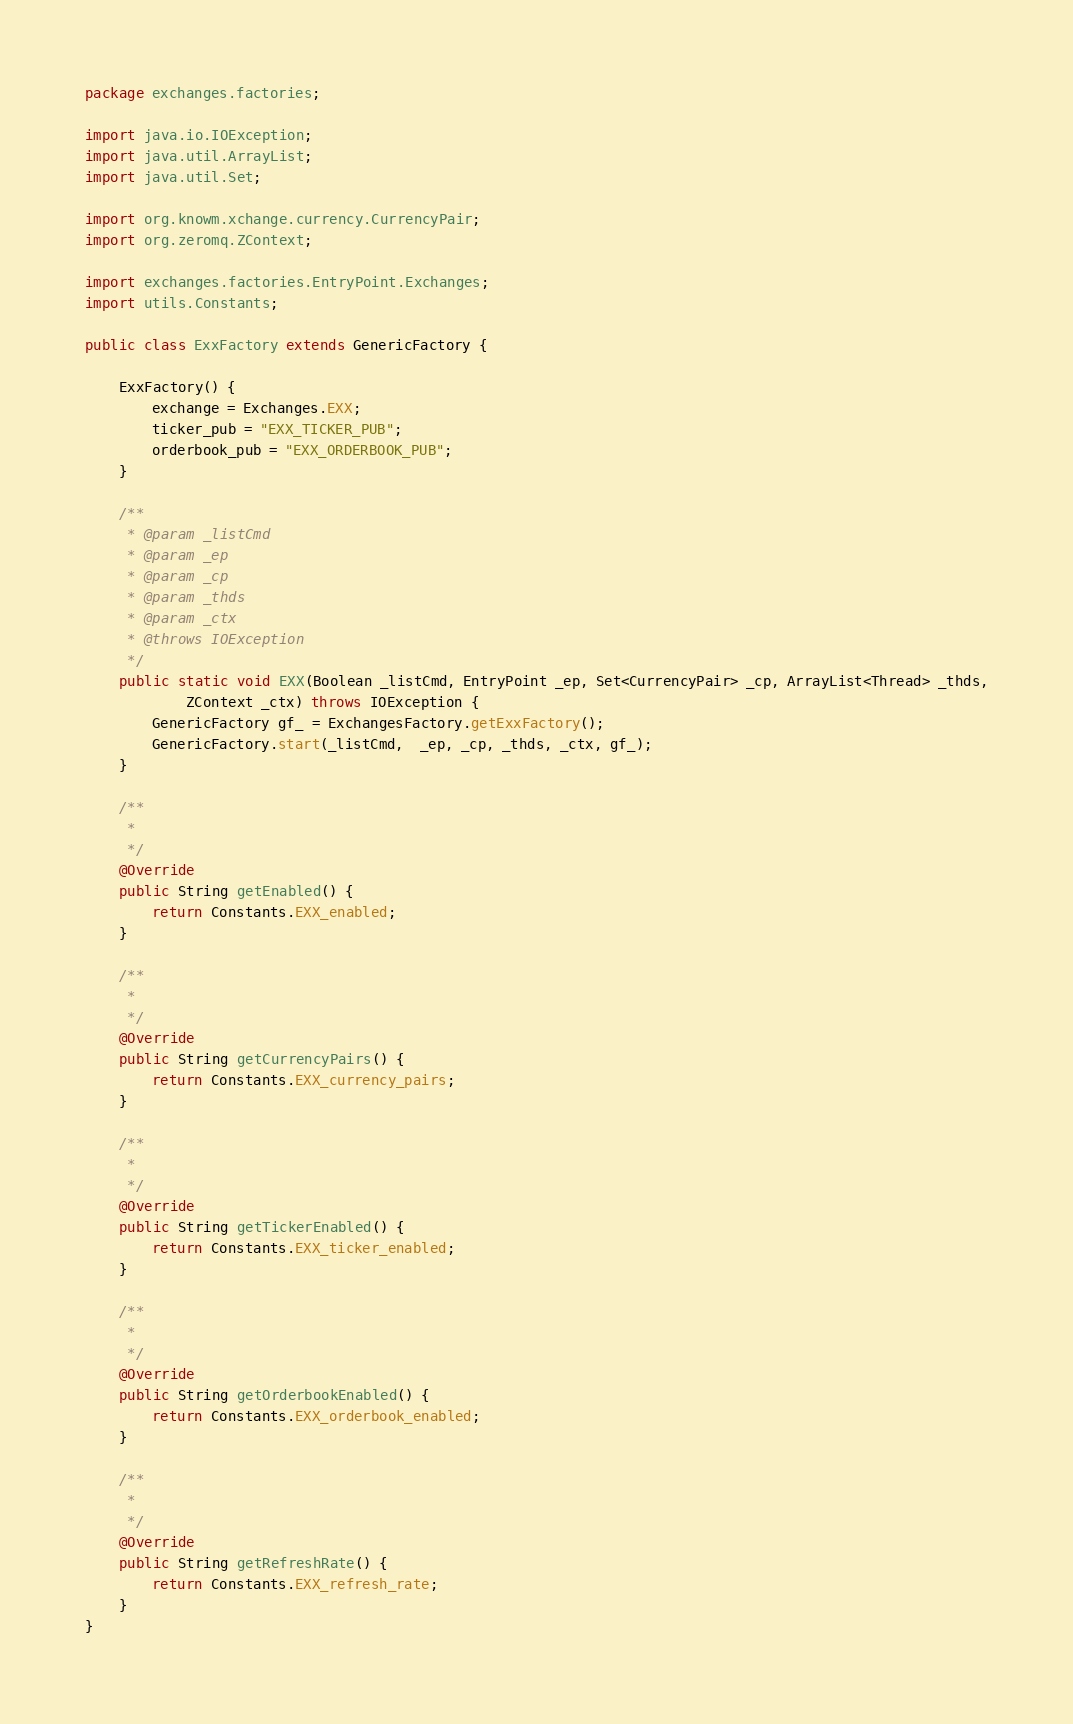Convert code to text. <code><loc_0><loc_0><loc_500><loc_500><_Java_>package exchanges.factories;

import java.io.IOException;
import java.util.ArrayList;
import java.util.Set;

import org.knowm.xchange.currency.CurrencyPair;
import org.zeromq.ZContext;

import exchanges.factories.EntryPoint.Exchanges;
import utils.Constants;

public class ExxFactory extends GenericFactory {

	ExxFactory() {
		exchange = Exchanges.EXX;
		ticker_pub = "EXX_TICKER_PUB";
		orderbook_pub = "EXX_ORDERBOOK_PUB";
	}

	/**
	 * @param _listCmd
	 * @param _ep
	 * @param _cp
	 * @param _thds
	 * @param _ctx
	 * @throws IOException
	 */
	public static void EXX(Boolean _listCmd, EntryPoint _ep, Set<CurrencyPair> _cp, ArrayList<Thread> _thds,
	        ZContext _ctx) throws IOException {
		GenericFactory gf_ = ExchangesFactory.getExxFactory();
		GenericFactory.start(_listCmd,  _ep, _cp, _thds, _ctx, gf_);
	}

	/**
	 *
	 */
	@Override
	public String getEnabled() {
		return Constants.EXX_enabled;
	}

	/**
	 *
	 */
	@Override
	public String getCurrencyPairs() {
		return Constants.EXX_currency_pairs;
	}

	/**
	 *
	 */
	@Override
	public String getTickerEnabled() {
		return Constants.EXX_ticker_enabled;
	}

	/**
	 *
	 */
	@Override
	public String getOrderbookEnabled() {
		return Constants.EXX_orderbook_enabled;
	}

	/**
	 *
	 */
	@Override
	public String getRefreshRate() {
		return Constants.EXX_refresh_rate;
	}
}</code> 